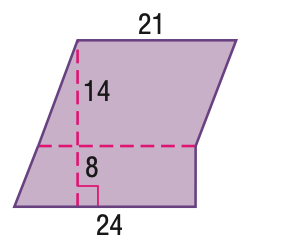Answer the mathemtical geometry problem and directly provide the correct option letter.
Question: Find the area of the figure. Round to the nearest tenth.
Choices: A: 462 B: 474 C: 486 D: 495 B 